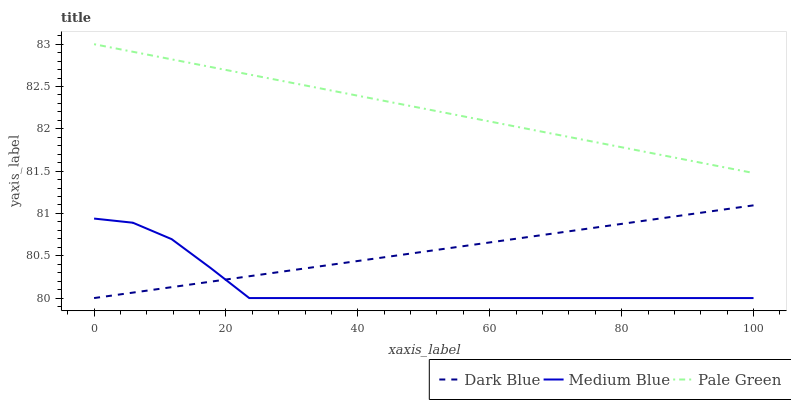Does Medium Blue have the minimum area under the curve?
Answer yes or no. Yes. Does Pale Green have the maximum area under the curve?
Answer yes or no. Yes. Does Pale Green have the minimum area under the curve?
Answer yes or no. No. Does Medium Blue have the maximum area under the curve?
Answer yes or no. No. Is Dark Blue the smoothest?
Answer yes or no. Yes. Is Medium Blue the roughest?
Answer yes or no. Yes. Is Pale Green the smoothest?
Answer yes or no. No. Is Pale Green the roughest?
Answer yes or no. No. Does Dark Blue have the lowest value?
Answer yes or no. Yes. Does Pale Green have the lowest value?
Answer yes or no. No. Does Pale Green have the highest value?
Answer yes or no. Yes. Does Medium Blue have the highest value?
Answer yes or no. No. Is Dark Blue less than Pale Green?
Answer yes or no. Yes. Is Pale Green greater than Dark Blue?
Answer yes or no. Yes. Does Medium Blue intersect Dark Blue?
Answer yes or no. Yes. Is Medium Blue less than Dark Blue?
Answer yes or no. No. Is Medium Blue greater than Dark Blue?
Answer yes or no. No. Does Dark Blue intersect Pale Green?
Answer yes or no. No. 